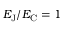Convert formula to latex. <formula><loc_0><loc_0><loc_500><loc_500>E _ { J } / E _ { C } = 1</formula> 